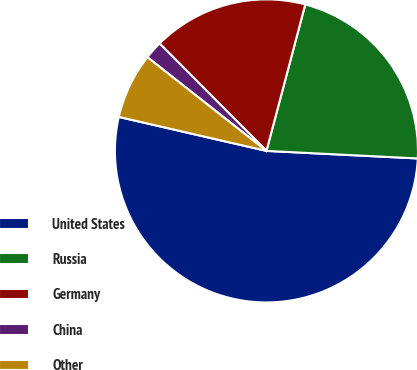Convert chart to OTSL. <chart><loc_0><loc_0><loc_500><loc_500><pie_chart><fcel>United States<fcel>Russia<fcel>Germany<fcel>China<fcel>Other<nl><fcel>52.81%<fcel>21.67%<fcel>16.58%<fcel>1.93%<fcel>7.01%<nl></chart> 